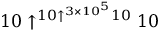Convert formula to latex. <formula><loc_0><loc_0><loc_500><loc_500>1 0 \uparrow ^ { 1 0 \uparrow ^ { 3 \times 1 0 ^ { 5 } } 1 0 } 1 0</formula> 